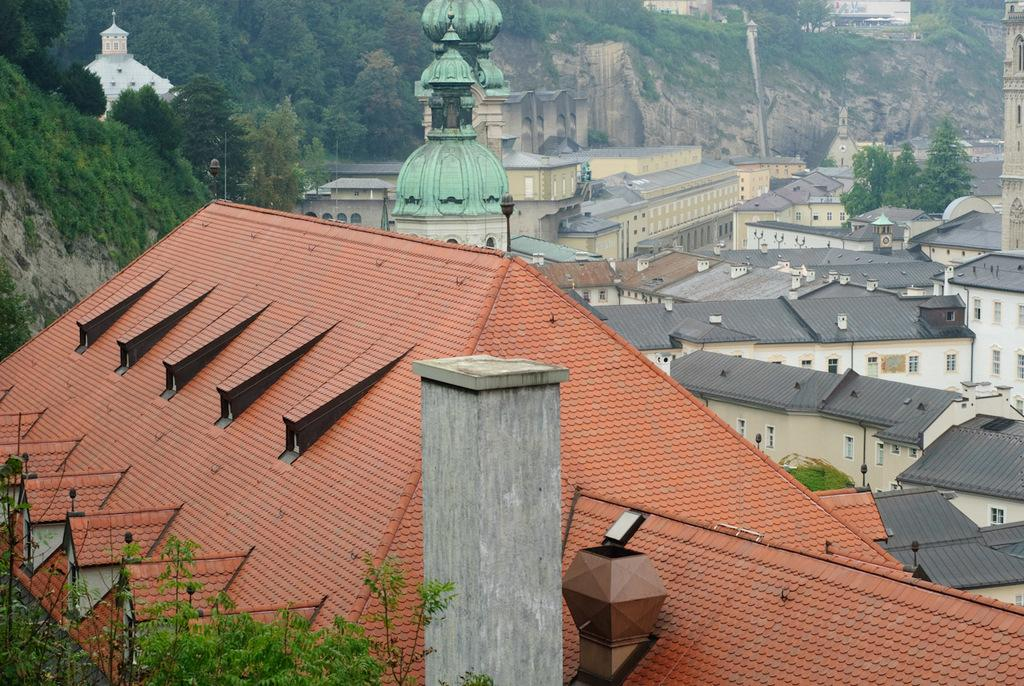What type of structures are present in the image? There are buildings in the image. What colors can be seen on the buildings? The buildings have brown, cream, and green colors. What can be seen in the background of the image? There are trees in the background of the image. What color are the trees? The trees have a green color. How many managers are present in the image? There is no mention of a manager or any people in the image; it only features buildings and trees. 